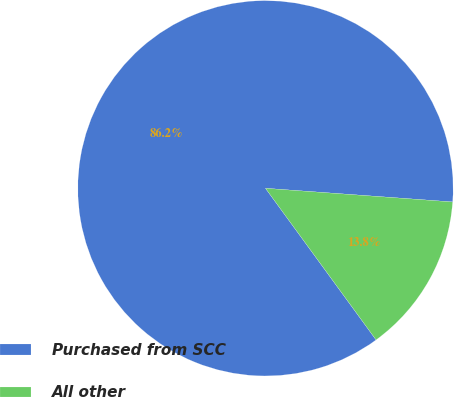Convert chart. <chart><loc_0><loc_0><loc_500><loc_500><pie_chart><fcel>Purchased from SCC<fcel>All other<nl><fcel>86.19%<fcel>13.81%<nl></chart> 